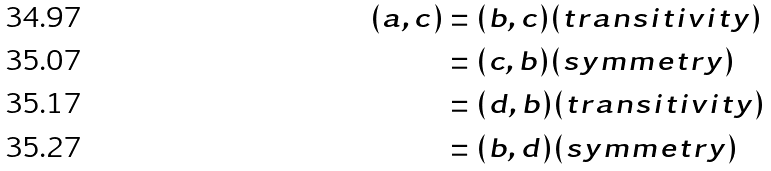Convert formula to latex. <formula><loc_0><loc_0><loc_500><loc_500>( a , c ) & = ( b , c ) ( t r a n s i t i v i t y ) \\ & = ( c , b ) ( s y m m e t r y ) \\ & = ( d , b ) ( t r a n s i t i v i t y ) \\ & = ( b , d ) ( s y m m e t r y )</formula> 